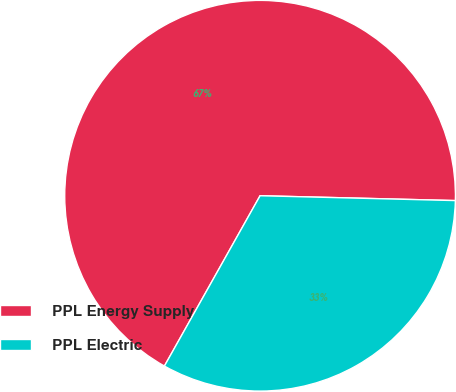<chart> <loc_0><loc_0><loc_500><loc_500><pie_chart><fcel>PPL Energy Supply<fcel>PPL Electric<nl><fcel>67.25%<fcel>32.75%<nl></chart> 